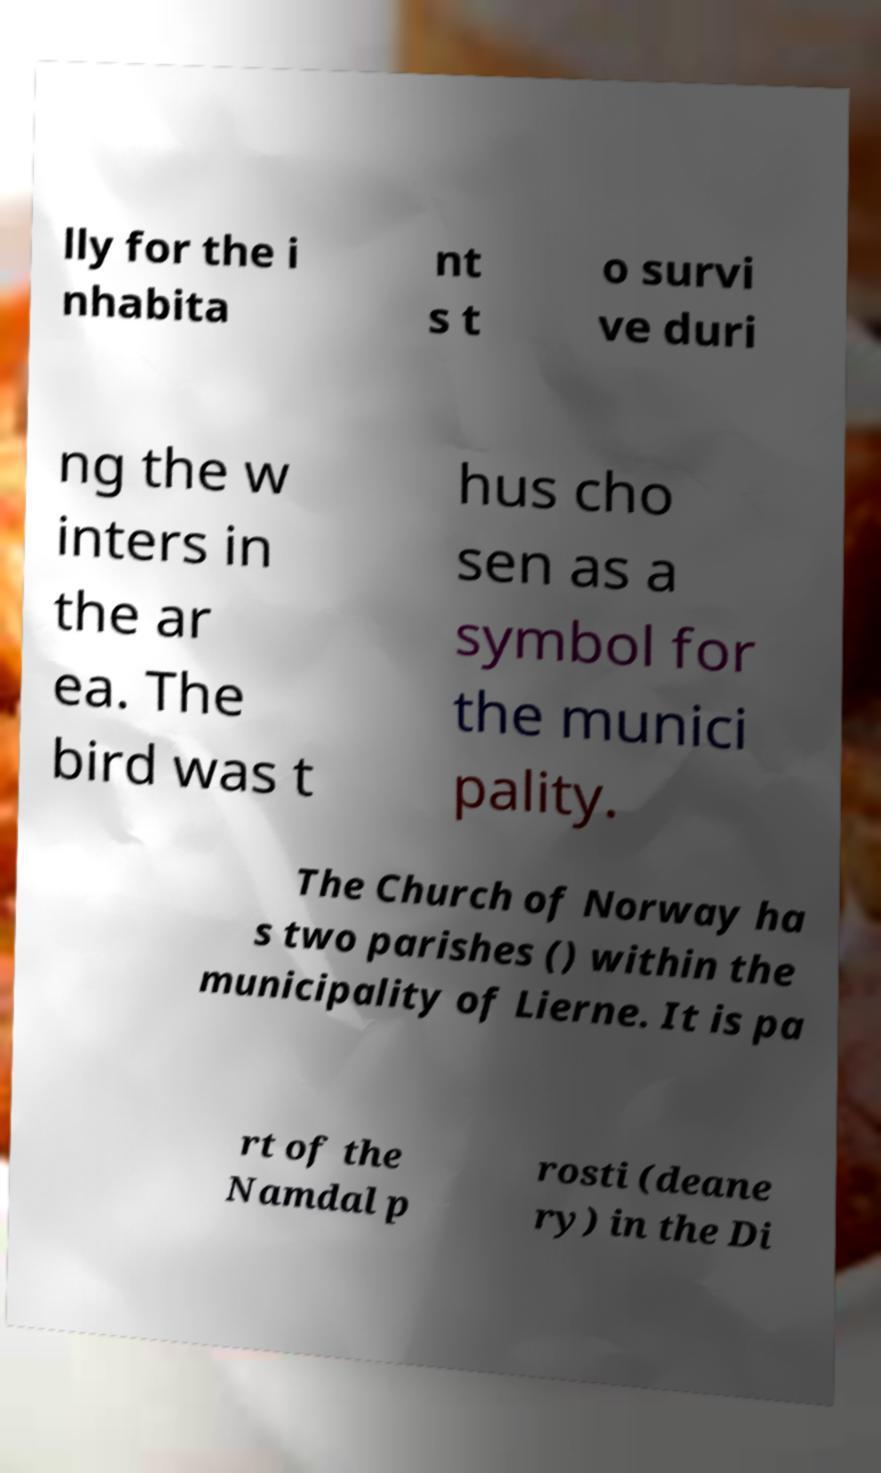Could you extract and type out the text from this image? lly for the i nhabita nt s t o survi ve duri ng the w inters in the ar ea. The bird was t hus cho sen as a symbol for the munici pality. The Church of Norway ha s two parishes () within the municipality of Lierne. It is pa rt of the Namdal p rosti (deane ry) in the Di 